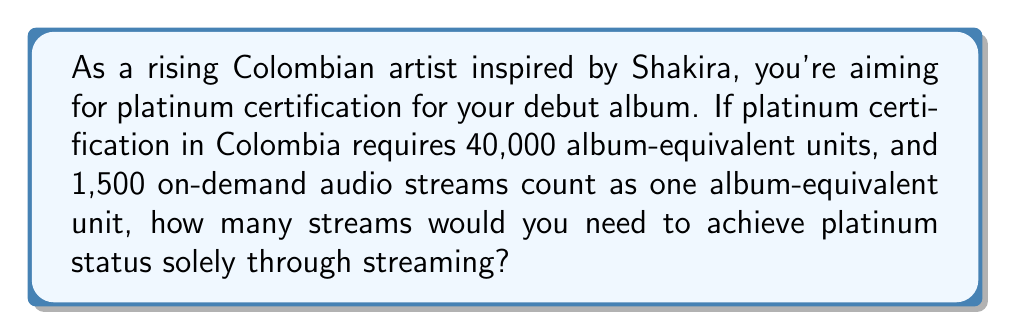Teach me how to tackle this problem. To solve this problem, we'll follow these steps:

1) First, let's define our variables:
   Let $x$ be the number of streams needed for platinum certification.

2) We know that 1,500 streams equal one album-equivalent unit:
   $$1,500 \text{ streams} = 1 \text{ album-equivalent unit}$$

3) We also know that 40,000 album-equivalent units are needed for platinum certification.

4) To find the number of streams, we need to multiply the number of album-equivalent units by the number of streams per unit:

   $$x = 40,000 \times 1,500$$

5) Let's calculate:
   $$x = 60,000,000$$

Therefore, you would need 60 million streams to achieve platinum certification solely through streaming.
Answer: 60,000,000 streams 